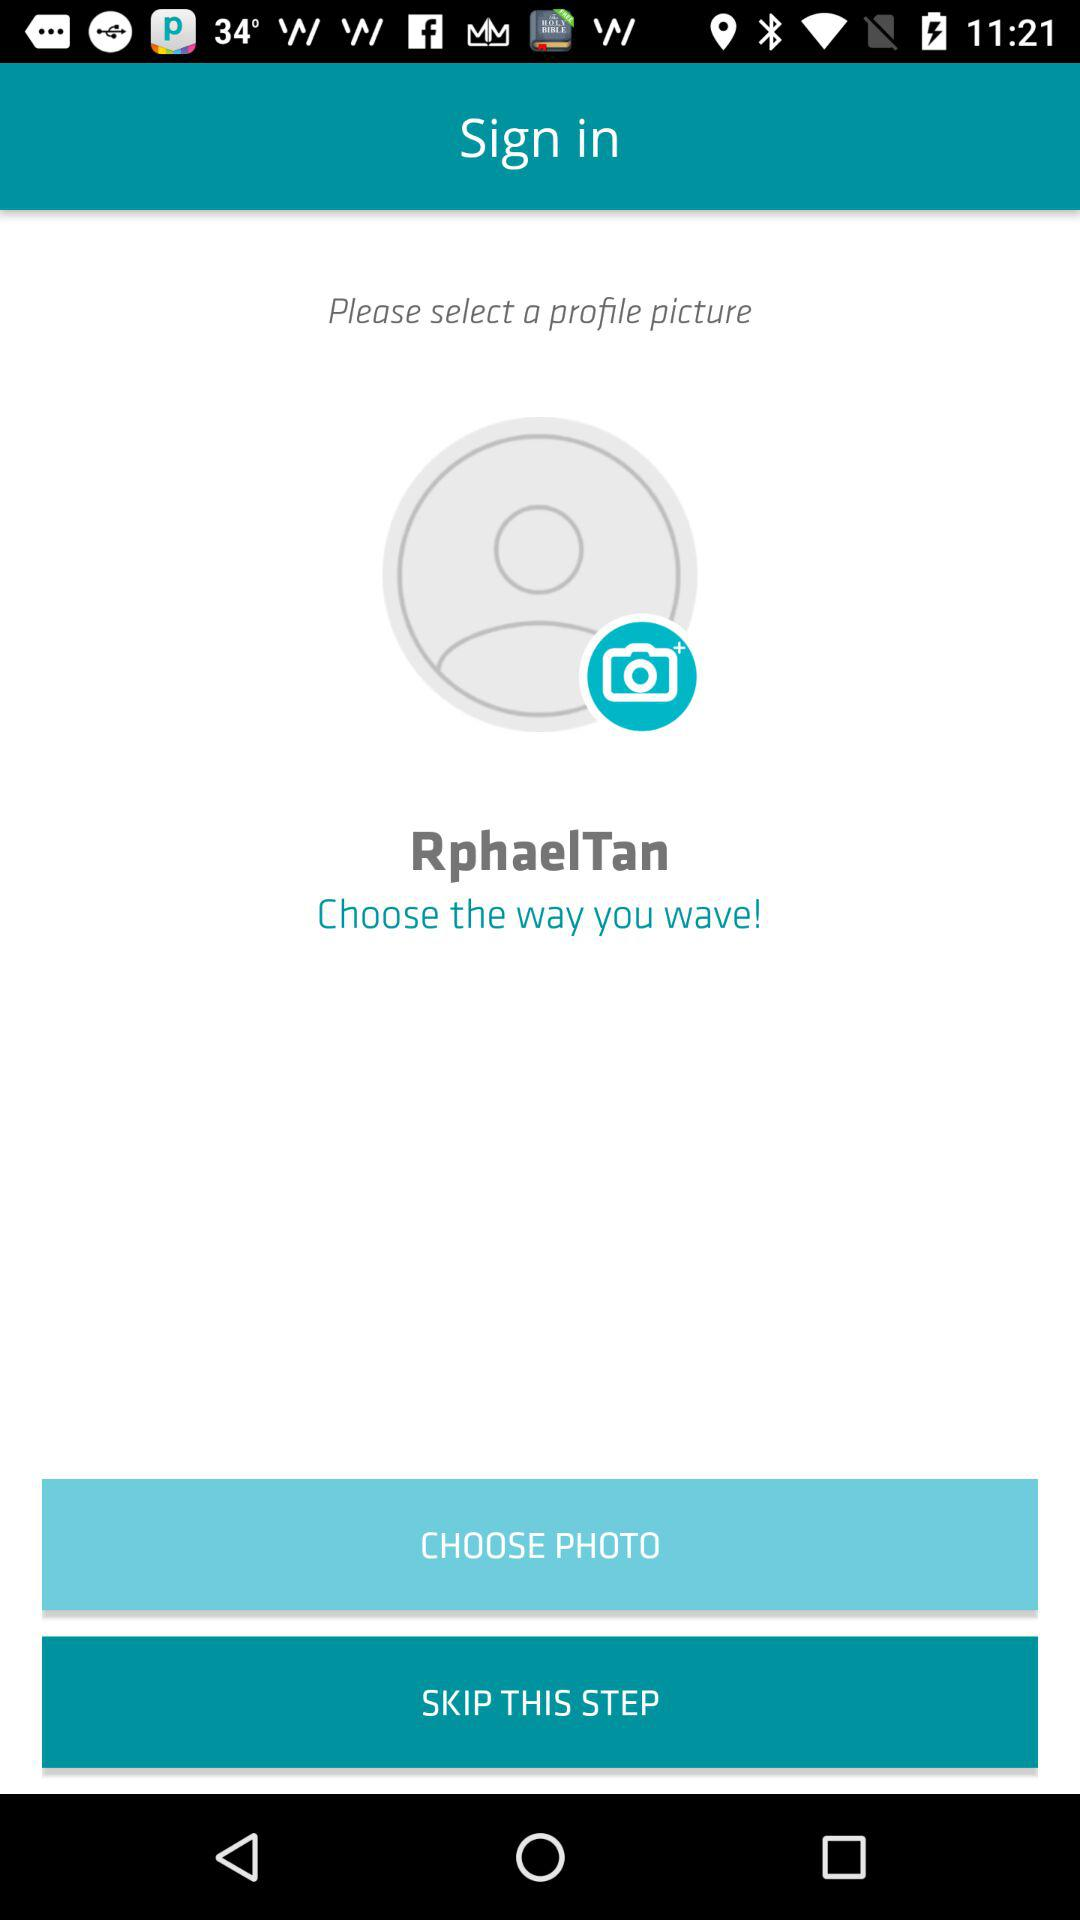What is the username? The username is "RphaelTan". 